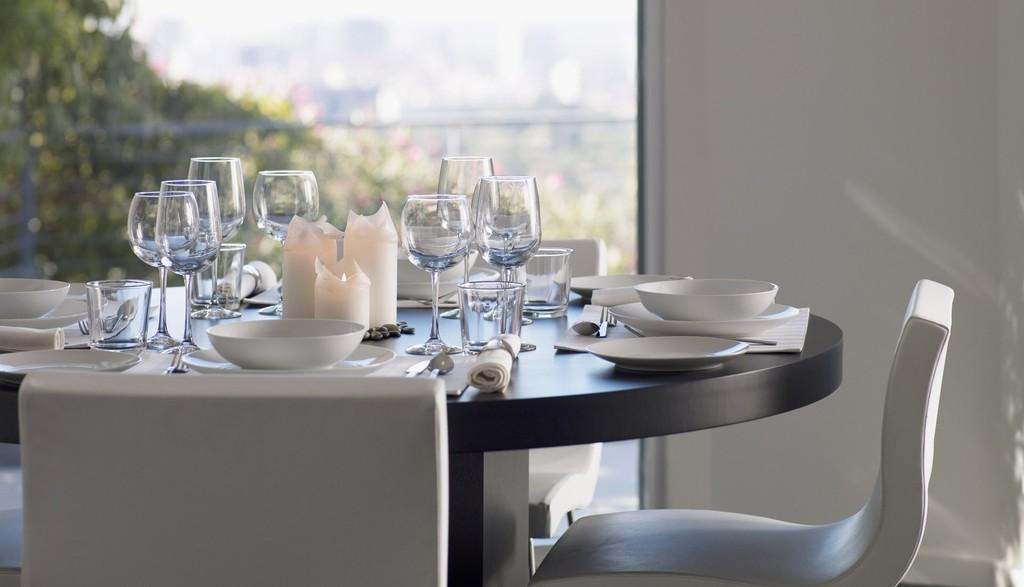What type of furniture is present in the image? There is a table and chairs in the image. What can be seen on the table? There are glasses, balls, and other objects on the table. How many chairs are visible in the image? The number of chairs is not specified, but there are chairs present in the image. What type of crime is being committed in the image? There is no indication of any crime being committed in the image. How do the nerves of the people in the image appear? The image does not show any people, so their nerves cannot be observed. 